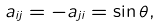<formula> <loc_0><loc_0><loc_500><loc_500>a _ { i j } = - a _ { j i } = \sin \theta ,</formula> 